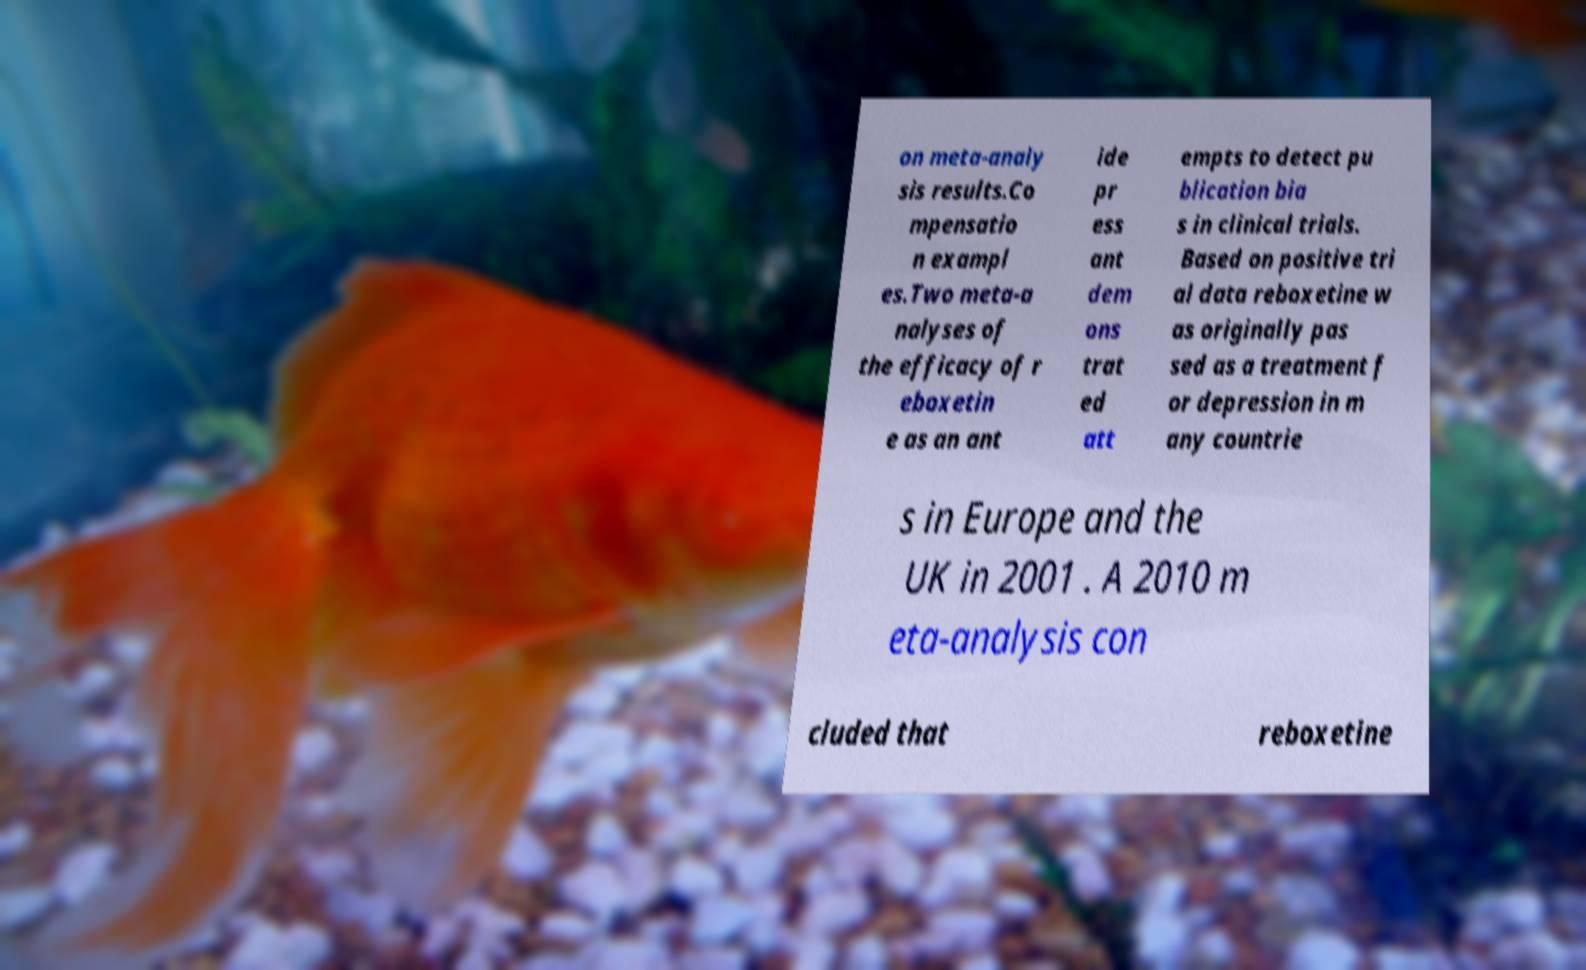What messages or text are displayed in this image? I need them in a readable, typed format. on meta-analy sis results.Co mpensatio n exampl es.Two meta-a nalyses of the efficacy of r eboxetin e as an ant ide pr ess ant dem ons trat ed att empts to detect pu blication bia s in clinical trials. Based on positive tri al data reboxetine w as originally pas sed as a treatment f or depression in m any countrie s in Europe and the UK in 2001 . A 2010 m eta-analysis con cluded that reboxetine 